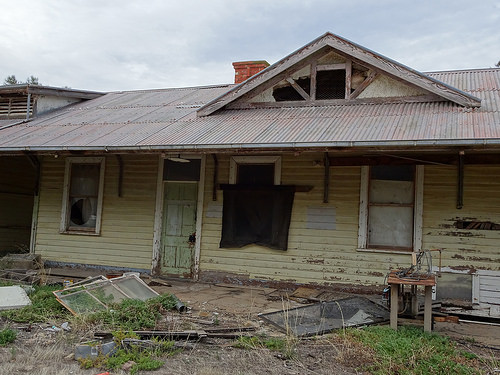<image>
Is the screen on the house? No. The screen is not positioned on the house. They may be near each other, but the screen is not supported by or resting on top of the house. 